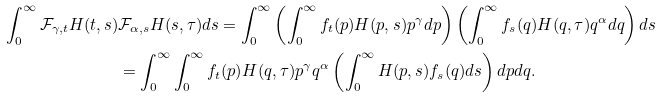Convert formula to latex. <formula><loc_0><loc_0><loc_500><loc_500>\int _ { 0 } ^ { \infty } \mathcal { F } _ { \gamma , t } H ( t , s ) & \mathcal { F } _ { \alpha , s } H ( s , \tau ) d s = \int _ { 0 } ^ { \infty } \left ( \int _ { 0 } ^ { \infty } f _ { t } ( p ) H ( p , s ) p ^ { \gamma } d p \right ) \left ( \int _ { 0 } ^ { \infty } f _ { s } ( q ) H ( q , \tau ) q ^ { \alpha } d q \right ) d s \\ & = \int _ { 0 } ^ { \infty } \int _ { 0 } ^ { \infty } f _ { t } ( p ) H ( q , \tau ) p ^ { \gamma } q ^ { \alpha } \left ( \int _ { 0 } ^ { \infty } H ( p , s ) f _ { s } ( q ) d s \right ) d p d q .</formula> 